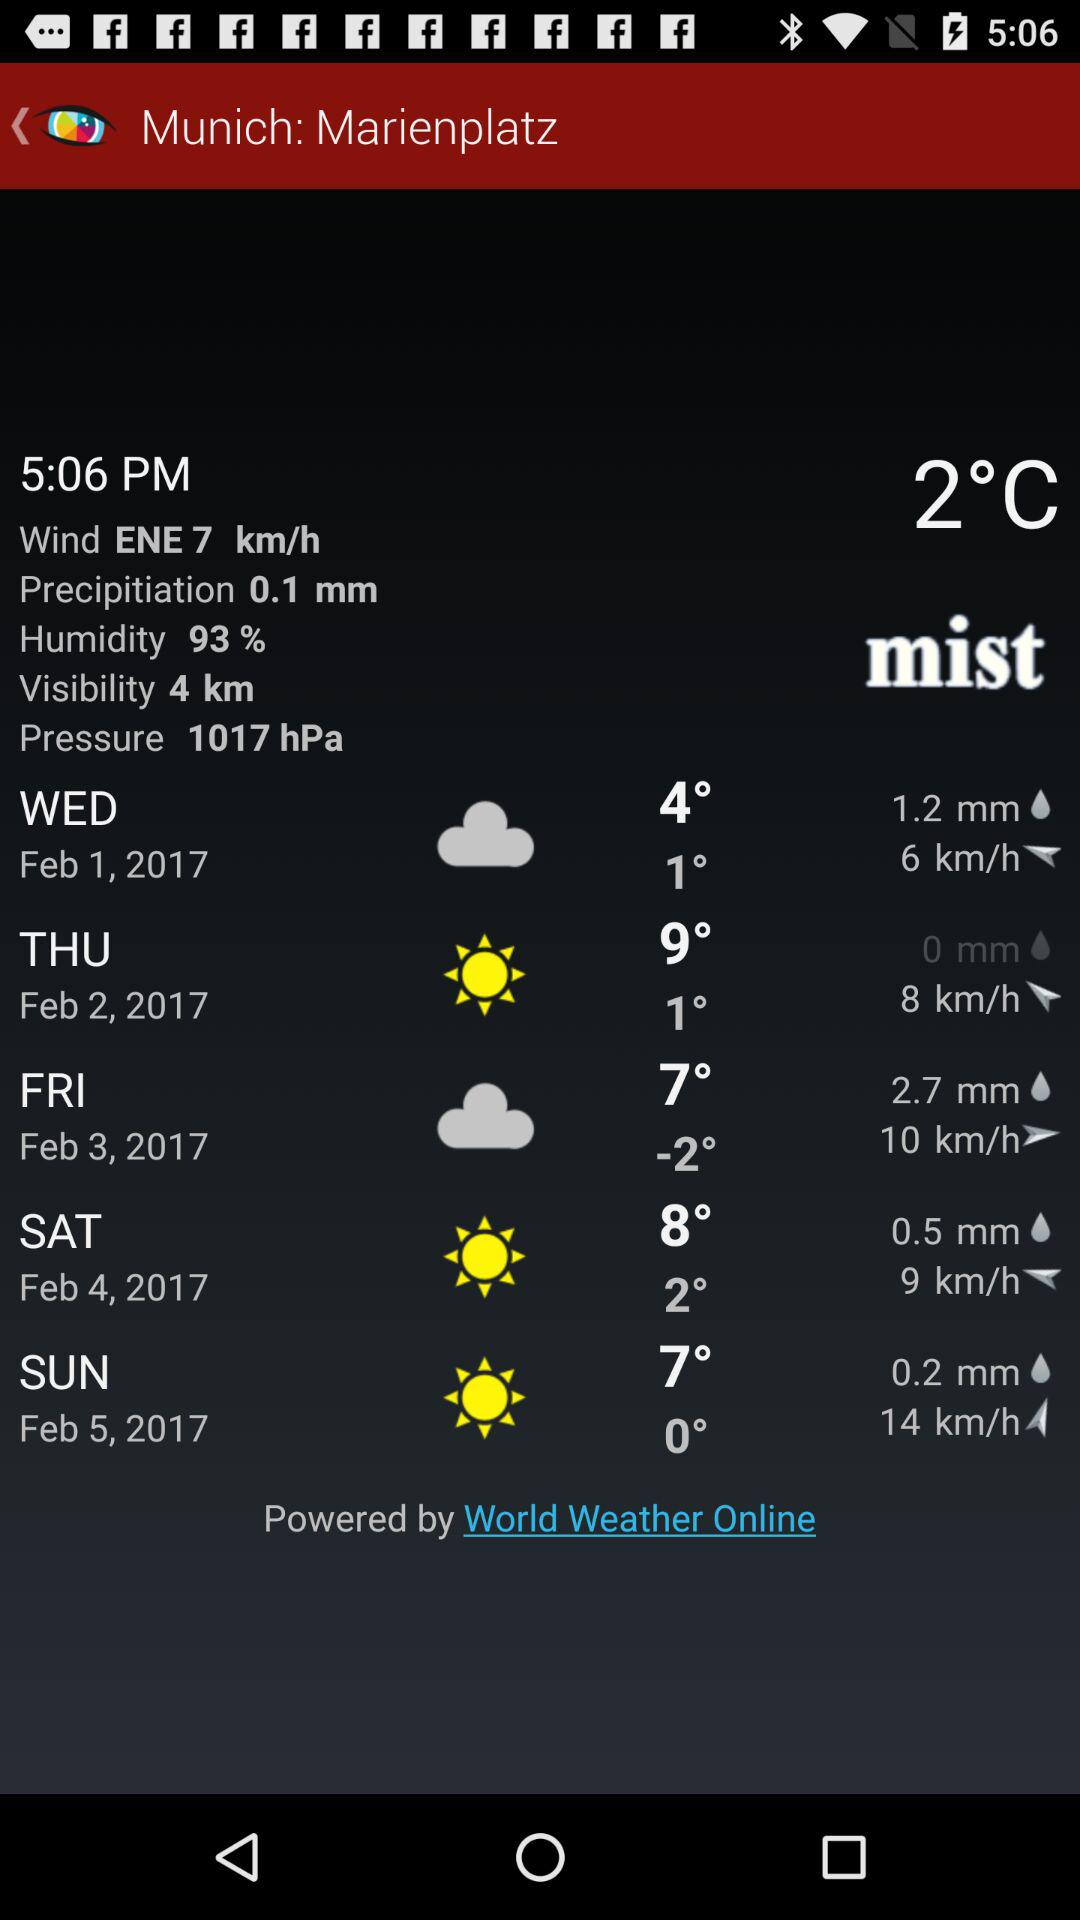What is the humidity? The humidity is 93%. 